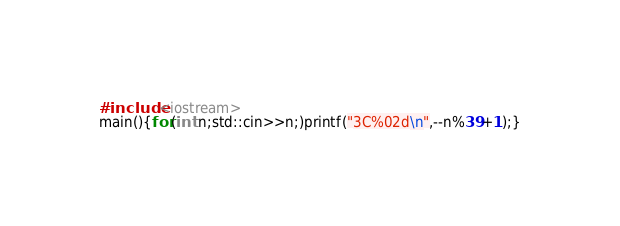Convert code to text. <code><loc_0><loc_0><loc_500><loc_500><_C++_>#include<iostream>
main(){for(int n;std::cin>>n;)printf("3C%02d\n",--n%39+1);}</code> 